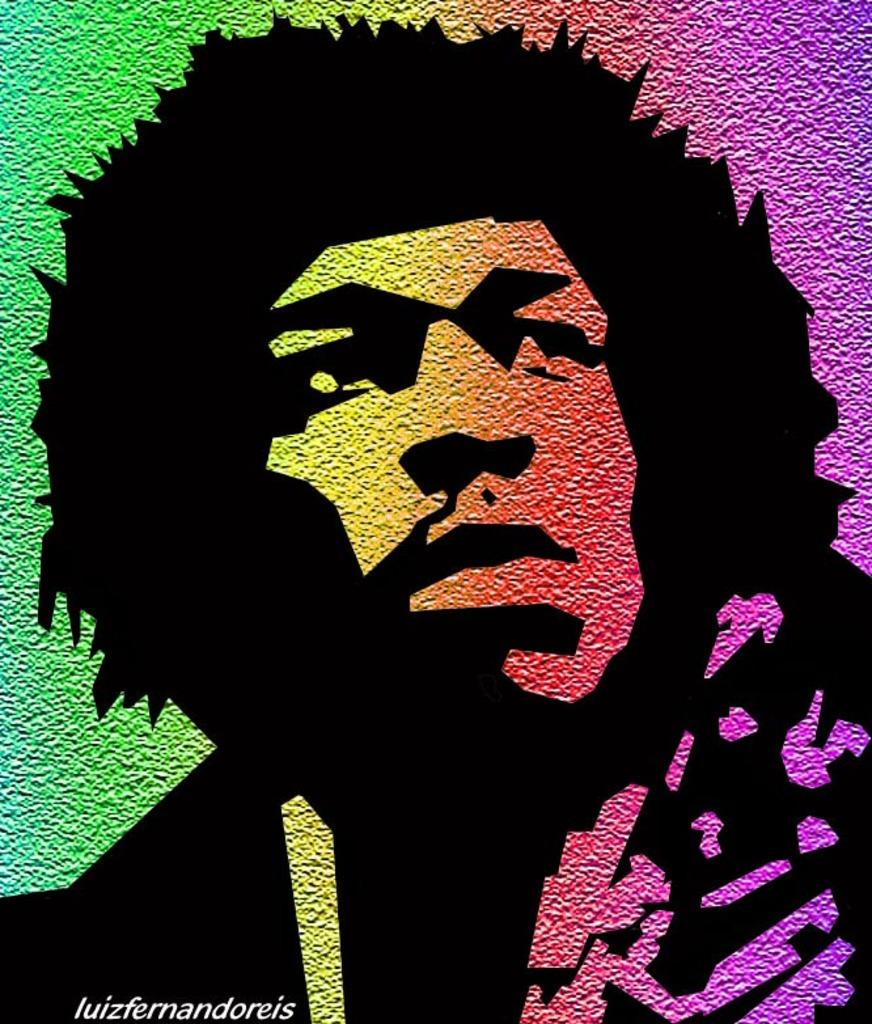What is the main subject of the image? There is a painting in the image. What does the painting depict? The painting depicts a person. Where is the painting located in the image? The painting is on a wall. How many balls are visible in the painting? There are no balls visible in the painting; it depicts a person. What type of birds can be seen flying in the painting? There are no birds visible in the painting; it depicts a person. 